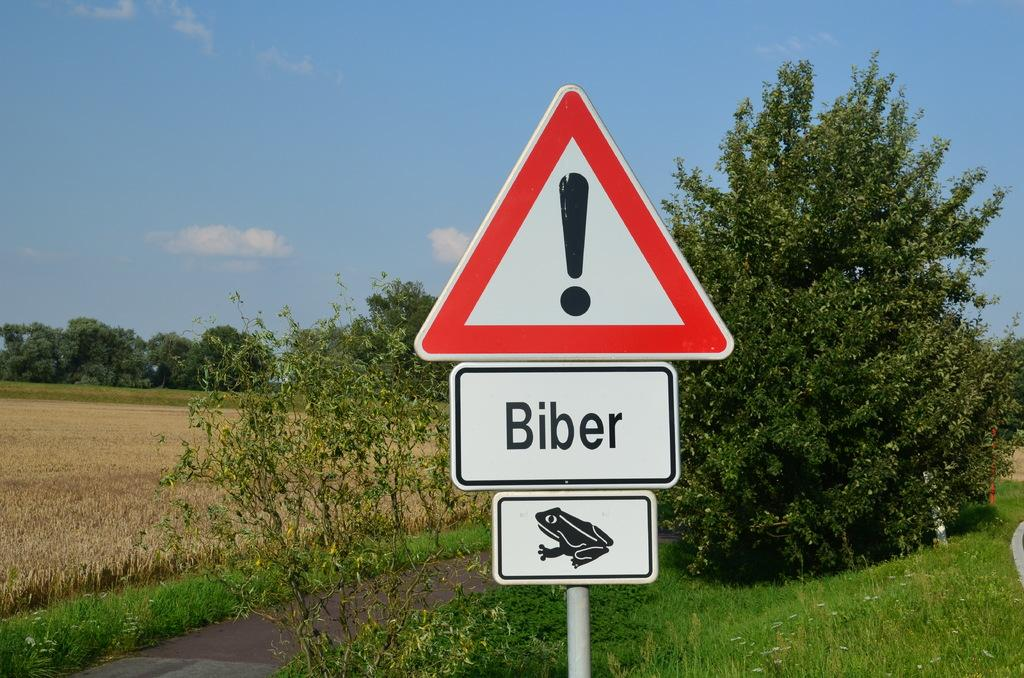Provide a one-sentence caption for the provided image. A warning sign with an exclamation mark tells you to watch out for Biber and frogs. 